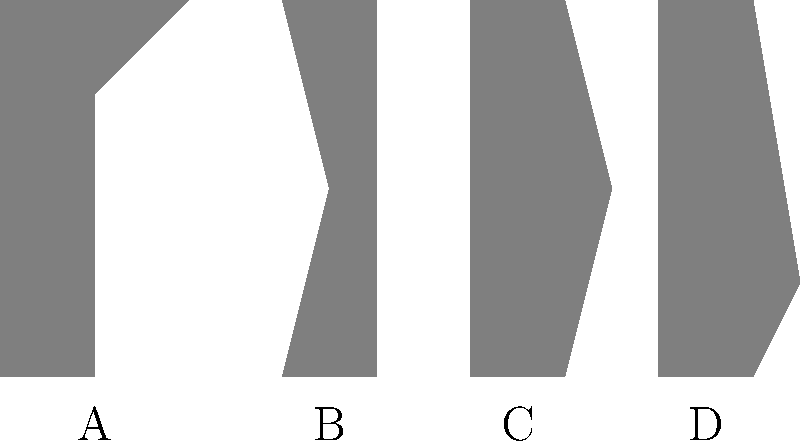Identify the iconic costume from classic Hollywood films represented by silhouette B: To identify the iconic costume represented by silhouette B, let's analyze each silhouette:

1. Silhouette A: This shape suggests a dress with a full skirt, likely representing Marilyn Monroe's famous white dress from "The Seven Year Itch."

2. Silhouette B: This outline shows a distinctive shape with a wide-brimmed hat and a curved silhouette. This is characteristic of Ingrid Bergman's iconic look in "Casablanca," where she wore a trench coat and a wide-brimmed hat.

3. Silhouette C: The shape indicates a dress with a cinched waist and full skirt, possibly representing Audrey Hepburn's black dress from "Breakfast at Tiffany's."

4. Silhouette D: This silhouette shows a slim, straight dress with a slight flare at the bottom, which could represent Rita Hayworth's famous strapless gown from "Gilda."

Given the distinctive wide-brimmed hat and the overall shape suggesting a trench coat, silhouette B most likely represents Ingrid Bergman's iconic look from the classic film "Casablanca" (1942).
Answer: Ingrid Bergman in "Casablanca" 